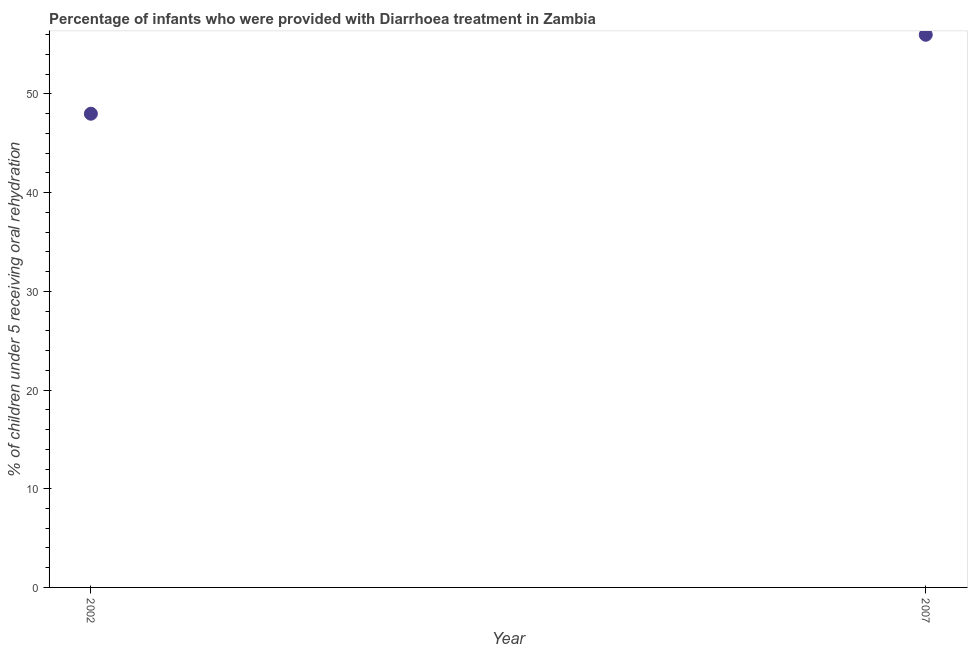What is the percentage of children who were provided with treatment diarrhoea in 2007?
Your answer should be compact. 56. Across all years, what is the maximum percentage of children who were provided with treatment diarrhoea?
Your answer should be very brief. 56. Across all years, what is the minimum percentage of children who were provided with treatment diarrhoea?
Give a very brief answer. 48. In which year was the percentage of children who were provided with treatment diarrhoea maximum?
Offer a terse response. 2007. In which year was the percentage of children who were provided with treatment diarrhoea minimum?
Provide a short and direct response. 2002. What is the sum of the percentage of children who were provided with treatment diarrhoea?
Offer a terse response. 104. What is the difference between the percentage of children who were provided with treatment diarrhoea in 2002 and 2007?
Provide a short and direct response. -8. In how many years, is the percentage of children who were provided with treatment diarrhoea greater than 22 %?
Your answer should be compact. 2. Do a majority of the years between 2007 and 2002 (inclusive) have percentage of children who were provided with treatment diarrhoea greater than 38 %?
Offer a terse response. No. What is the ratio of the percentage of children who were provided with treatment diarrhoea in 2002 to that in 2007?
Offer a very short reply. 0.86. Is the percentage of children who were provided with treatment diarrhoea in 2002 less than that in 2007?
Your answer should be compact. Yes. In how many years, is the percentage of children who were provided with treatment diarrhoea greater than the average percentage of children who were provided with treatment diarrhoea taken over all years?
Your answer should be compact. 1. How many dotlines are there?
Provide a succinct answer. 1. Are the values on the major ticks of Y-axis written in scientific E-notation?
Offer a very short reply. No. What is the title of the graph?
Make the answer very short. Percentage of infants who were provided with Diarrhoea treatment in Zambia. What is the label or title of the X-axis?
Keep it short and to the point. Year. What is the label or title of the Y-axis?
Make the answer very short. % of children under 5 receiving oral rehydration. What is the % of children under 5 receiving oral rehydration in 2002?
Make the answer very short. 48. What is the ratio of the % of children under 5 receiving oral rehydration in 2002 to that in 2007?
Provide a short and direct response. 0.86. 